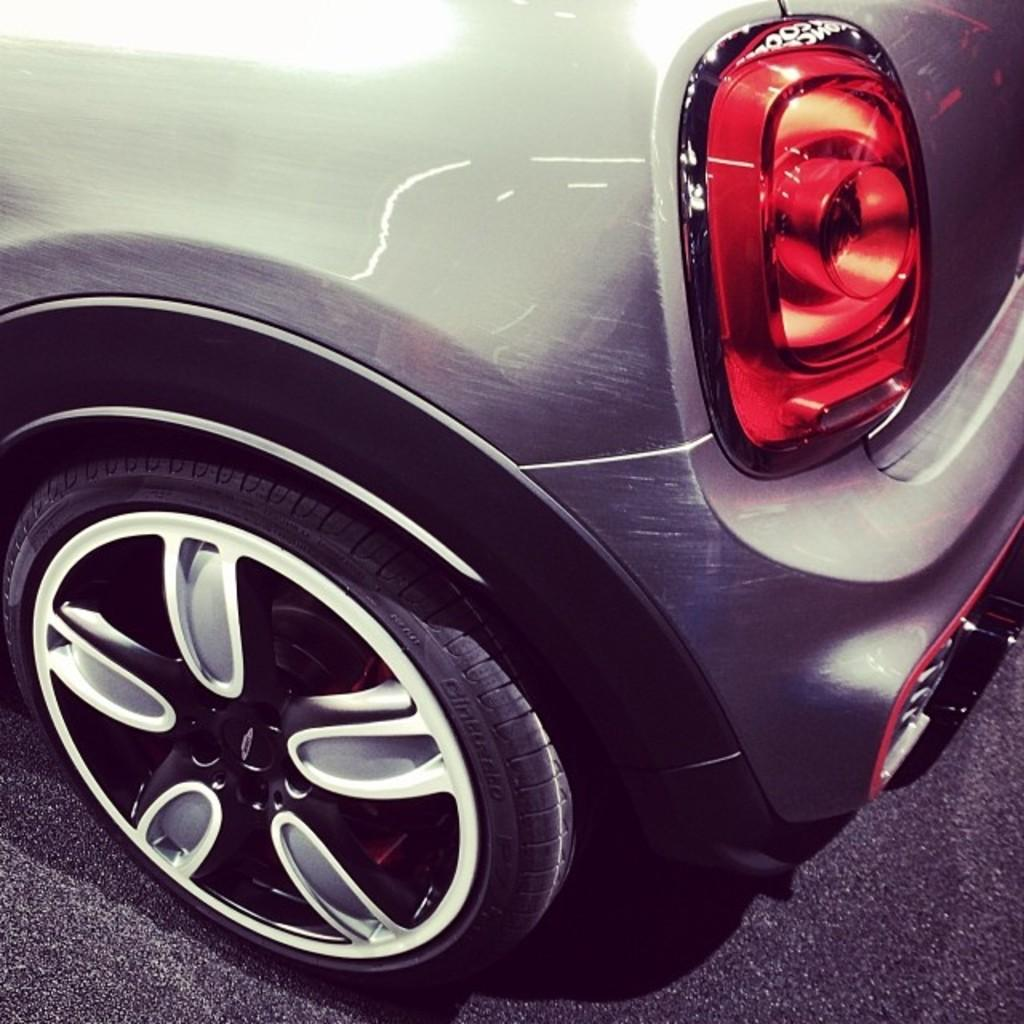What part of the car is visible in the image? The image shows the back side of a car. What are the car's wheels like? The car has wheels. What safety feature is present on the car? The car has a red light. What color is the car in the image? The car is gray in color. How many legs does the car have in the image? Cars do not have legs; they have wheels. In this image, the car has four wheels. 